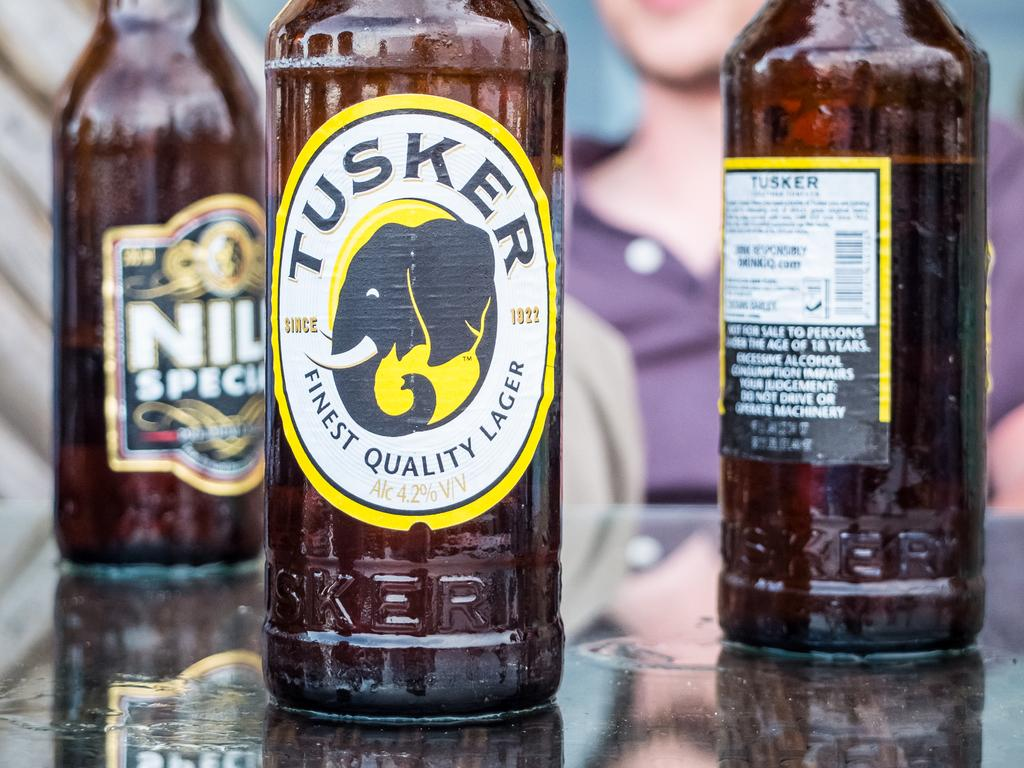<image>
Create a compact narrative representing the image presented. Three lager bottles, one with Tusker written on it. 